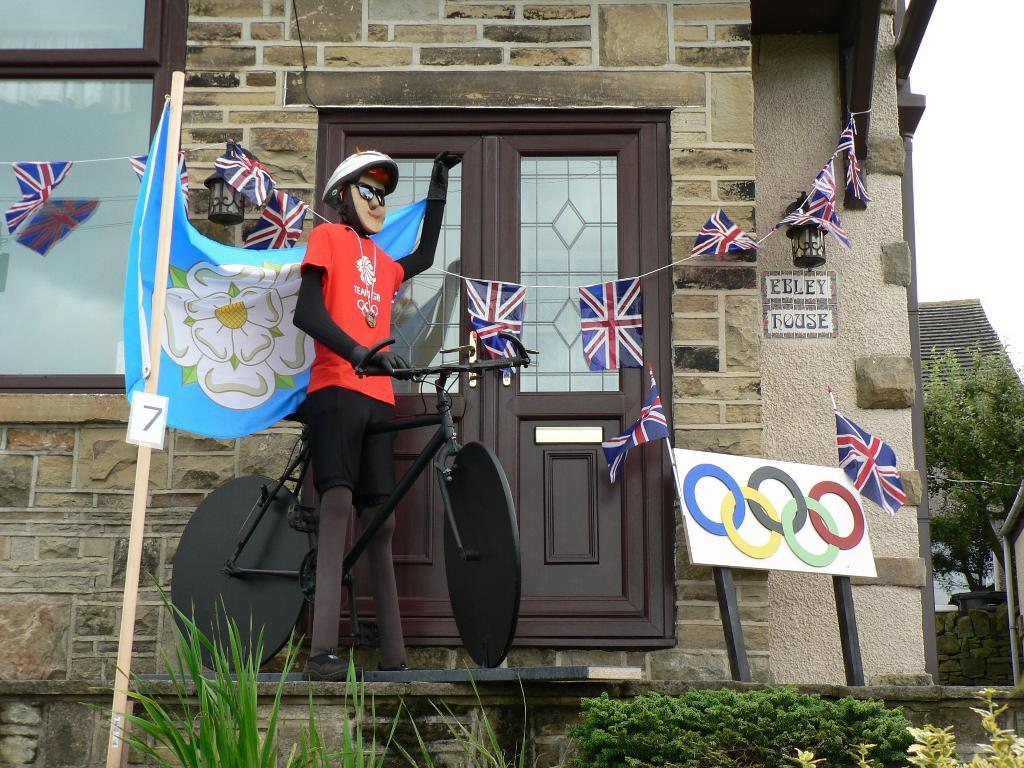What object is present in the image that is meant for play? There is a toy in the image. Where is the toy located in the image? The toy is sitting on a bicycle. What other object can be seen near the toy? There is a door beside the toy. What type of key is used to unlock the door in the image? There is no key present in the image, and the door's locking mechanism is not visible. How many people are downtown in the image? There is no indication of a downtown area or people in the image. 